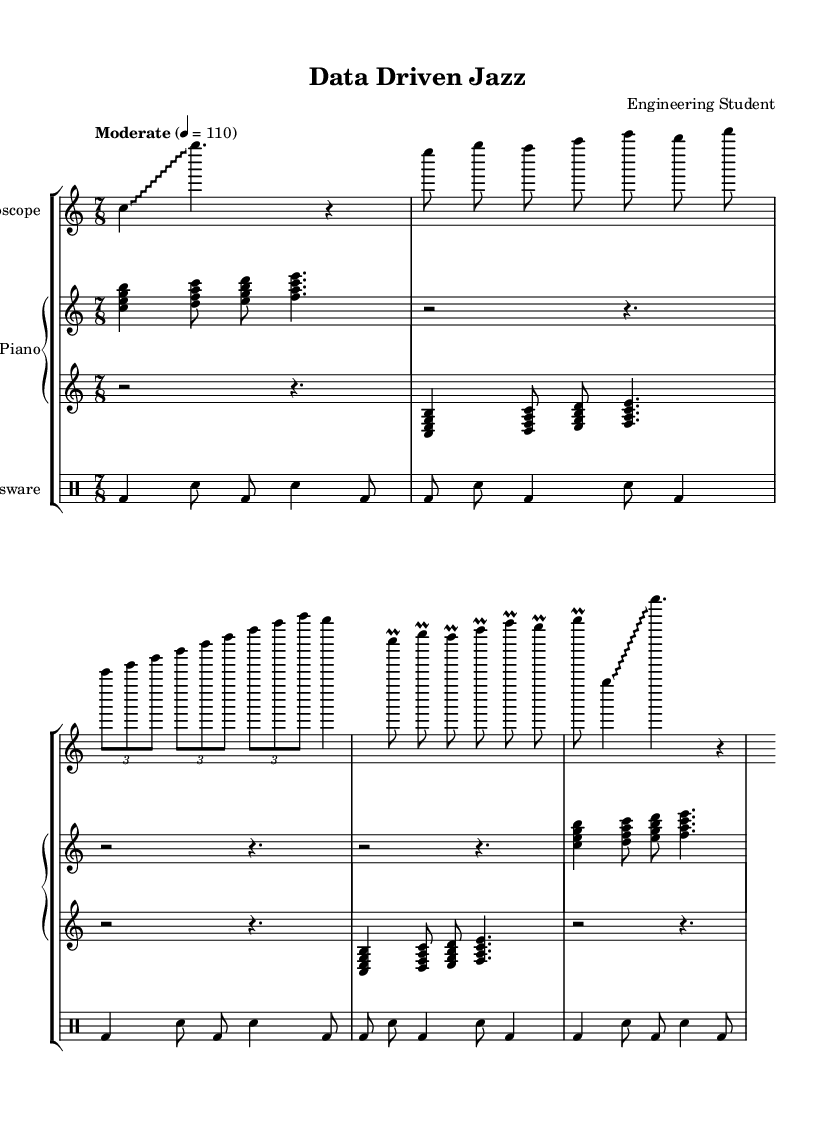What is the time signature of this music? The time signature is located at the beginning of the sheet music, which indicates a 7/8 time signature. This means there are 7 beats in each measure, and the eighth note is one beat.
Answer: 7/8 What is the tempo marking of the piece? The tempo marking is found above the staff, indicating the speed of the music. Here, it states "Moderate" with a metronome marking of 4 = 110, meaning there are 110 beats per minute.
Answer: Moderate, 110 How many voices are used in the prepared piano section? The prepared piano section is divided into two staffs (upper and lower), indicating two distinct voices or parts playing together.
Answer: Two Which unusual instrument is represented as an oscillator? In the first staff, the label indicates "Oscilloscope", which represents the unusual instrument being used in this experimental jazz piece.
Answer: Oscilloscope How many measures are there in the drumming section? By counting the individual rhythmic groupings in the lab glassware section, there are 5 measures represented, as indicated by each line terminating with a bar line.
Answer: Five What type of jazz does this composition demonstrate? Given the incorporation of unusual instruments and found sounds, this composition exemplifies experimental jazz, which pushes traditional boundaries and explores new sound textures.
Answer: Experimental jazz 